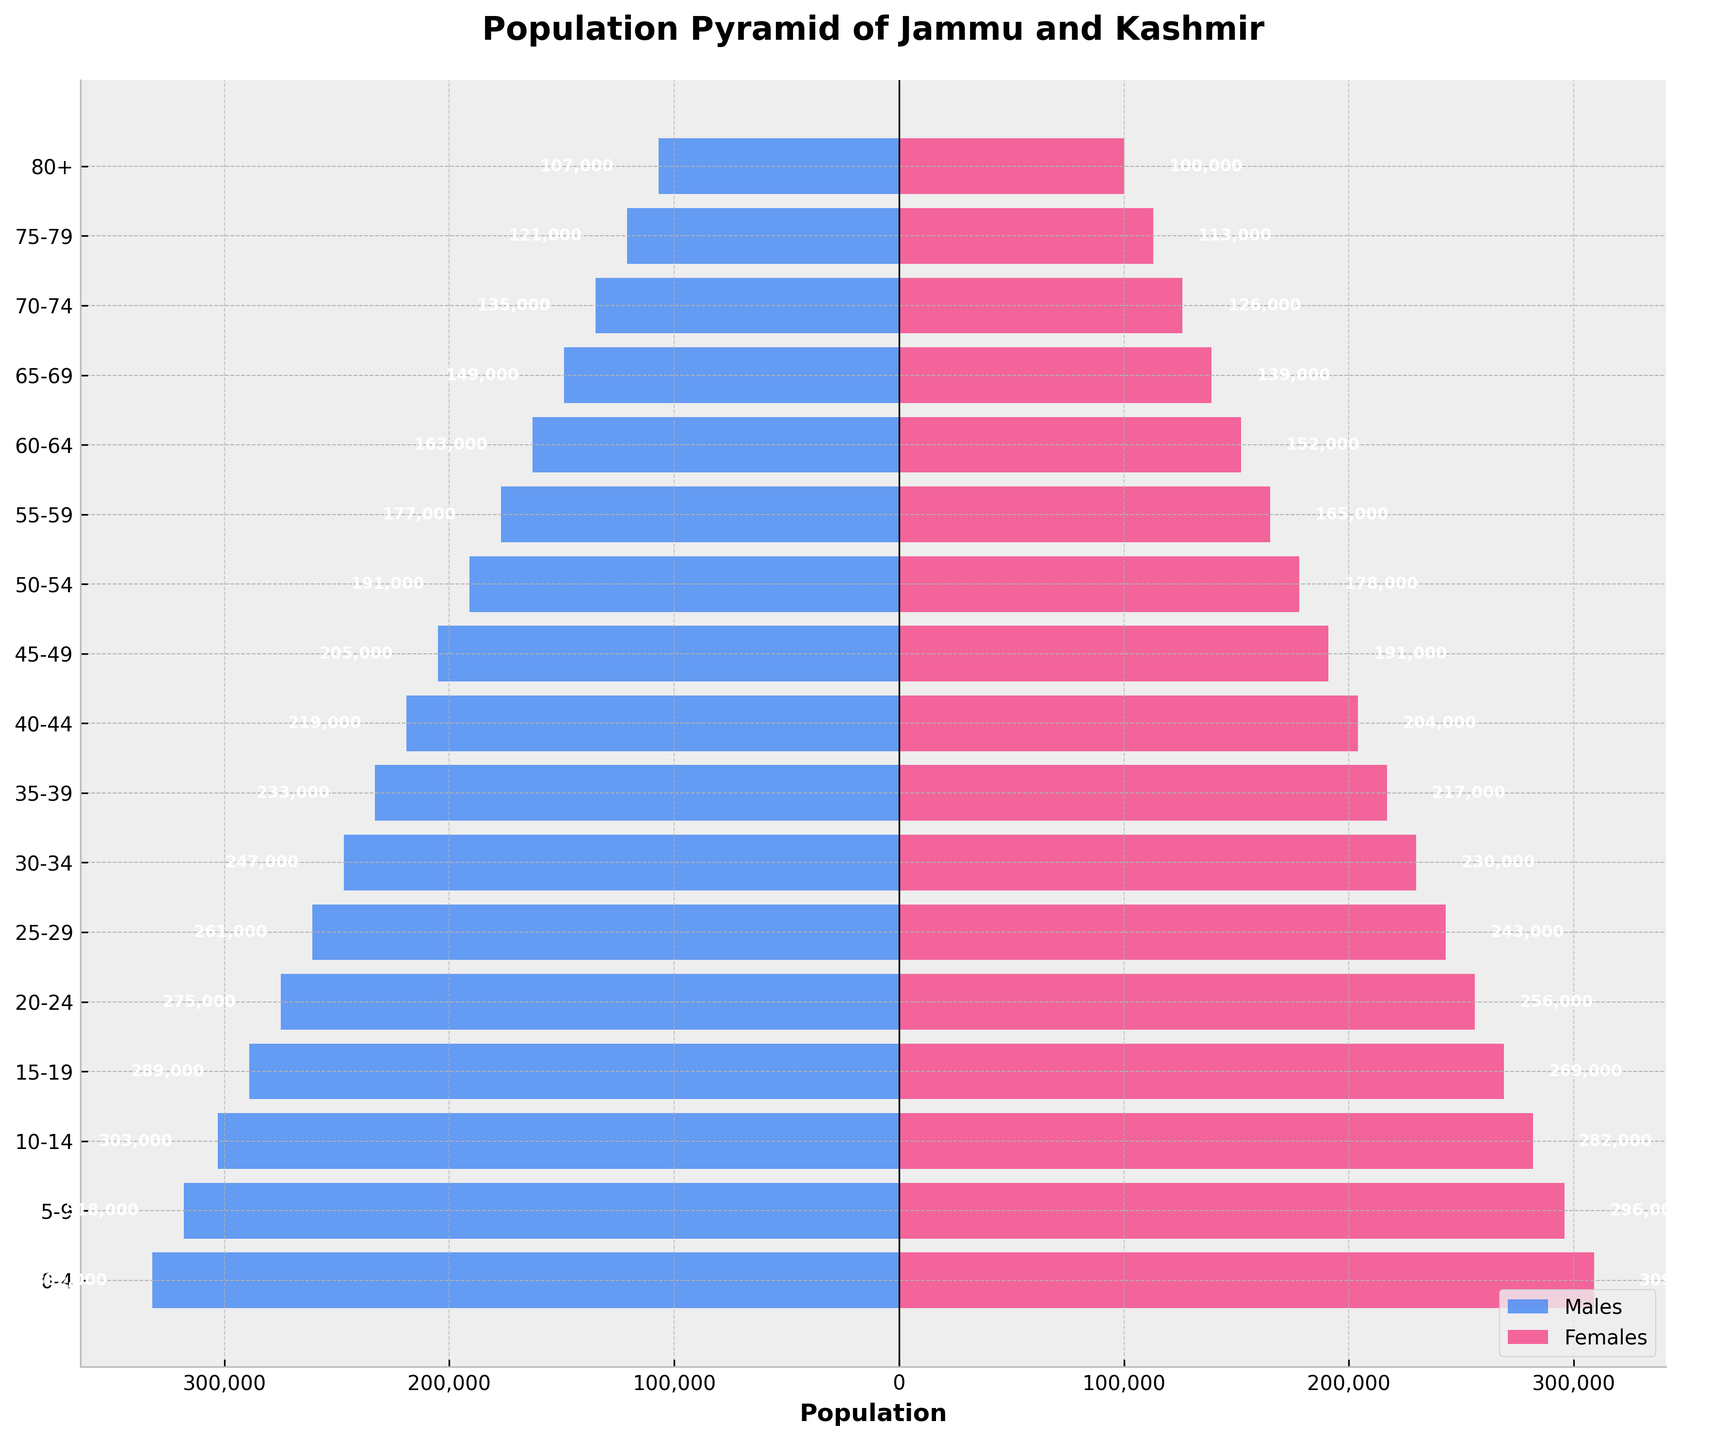What is the title of the figure? The title is generally found at the top of the figure and is designed to give an overview of what the figure represents. Here, it is shown in bold at the top center of the plot.
Answer: Population Pyramid of Jammu and Kashmir Which colors represent males and females in the population pyramid? The colors can be visually identified by looking at the legend which is typically located at a corner of the figure. Here, '#4287f5' (blue) represents males and '#f54287' (pink) represents females.
Answer: Males: blue, Females: pink What age group has the largest male population? To find the age group with the largest male population, look at the length of bars pointing left (representing males). The longest bar corresponds to the age group 0-4.
Answer: 0-4 How many age groups are represented in the population pyramid? Count the number of age groups listed on the y-axis or in the 'Age Group' column of the data. Each unique age group corresponds to a single bar pair.
Answer: 16 What is the population of females aged 60-64? Locate the bar representing females aged 60-64 and find the number labeled directly on the bar.
Answer: 152,000 Which gender has a generally larger population in the age groups 0-4 through 20-24? To determine this, compare the lengths of bars representing males and females for each of these age groups. The males' bars are consistently longer across these age groups.
Answer: Males How does the population of 75-79 compare with that of 80+ for males? Compare the lengths of the horizontal bars corresponding to the two age groups for males. Here, the bar for 75-79 is longer than the bar for 80+.
Answer: The population of males aged 75-79 is larger than that of 80+ What is the total population of males and females in the 50-54 age group? Sum up the populations of males and females in the 50-54 age group which are 191,000 and 178,000 respectively.
Answer: 369,000 Which age group has the smallest population for both genders combined? Compare the total (absolute) lengths of bars for both genders in each age group. The 80+ group has the shortest combined bars.
Answer: 80+ What trends can be observed about the aging population from this pyramid? Observing the bars, one can see the height of the bars for both genders gradually decreases with increasing age, indicating that the population size diminishes in the older age groups, reflecting an aging population.
Answer: The population size diminishes in older age groups 